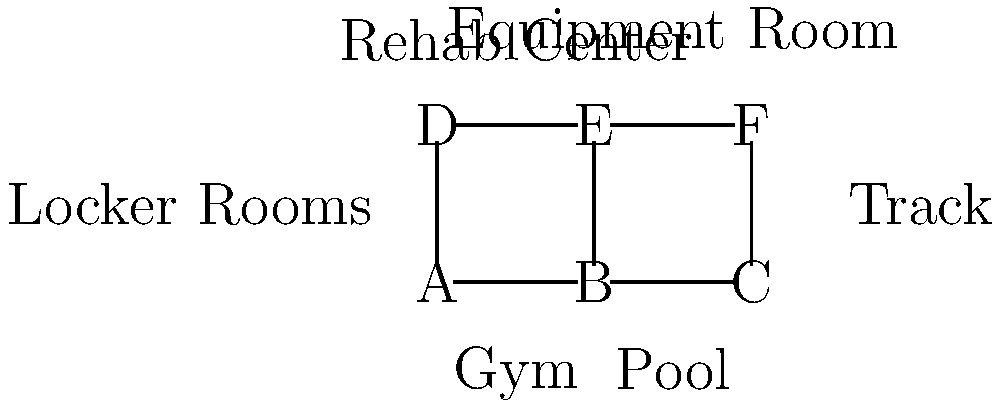In the floor plan of a sports training facility shown above, each node represents a different area. If an athlete needs to visit all areas exactly once, starting and ending at the locker rooms (node D), what is the minimum number of times they would need to pass through the rehab center (node E)? To solve this problem, we need to analyze the layout and find the most efficient path that visits all nodes once, starting and ending at node D (locker rooms). Let's break it down step-by-step:

1. We need to visit all 6 nodes (A, B, C, D, E, F) exactly once, starting and ending at D.

2. Node E (rehab center) is central to the layout, connecting to 4 other nodes (A, B, D, F).

3. The most efficient path will likely use E as a hub to reach other areas.

4. One possible efficient path is: D -> A -> B -> E -> F -> C -> D

5. In this path, we pass through E only once.

6. We can prove this is optimal:
   - To reach B or F from D, we must pass through either A or E.
   - To reach C from any other node, we must pass through either B or F.
   - Therefore, at least one passage through E is necessary to connect all nodes.

7. Any path that avoids E would require more steps and be less efficient.

Therefore, the minimum number of times an athlete needs to pass through the rehab center (E) to visit all areas exactly once, starting and ending at the locker rooms (D), is 1.
Answer: 1 